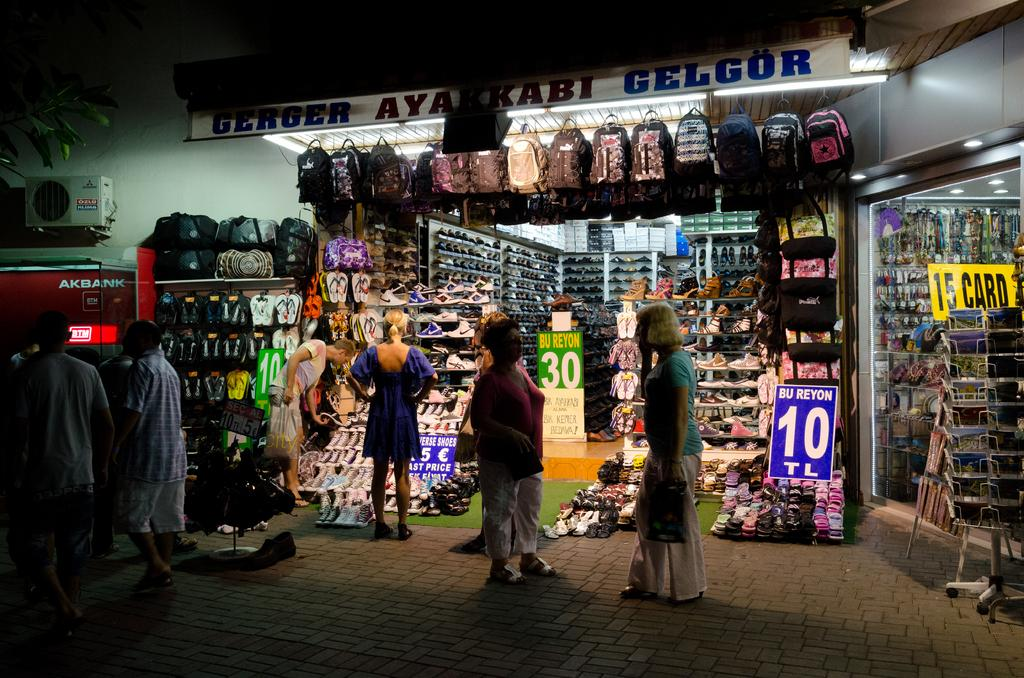Who or what can be seen in the image? There are people in the image. What type of establishments are visible in the image? There are shops in the image. What type of clothing accessory is visible in the image? Footwear is visible in the image. What type of personal item is present in the image? Bags are present in the image. What type of signage is present in the image? Boards are present in the image. What type of electronic device is visible in the image? A device is visible in the image. What type of structure is present in the image? There is a wall in the image. What type of objects are present in the image? There are objects in the image. Where is the bat hiding in the image? There is no bat present in the image. How does the scarecrow interact with the objects in the image? There is no scarecrow present in the image. 